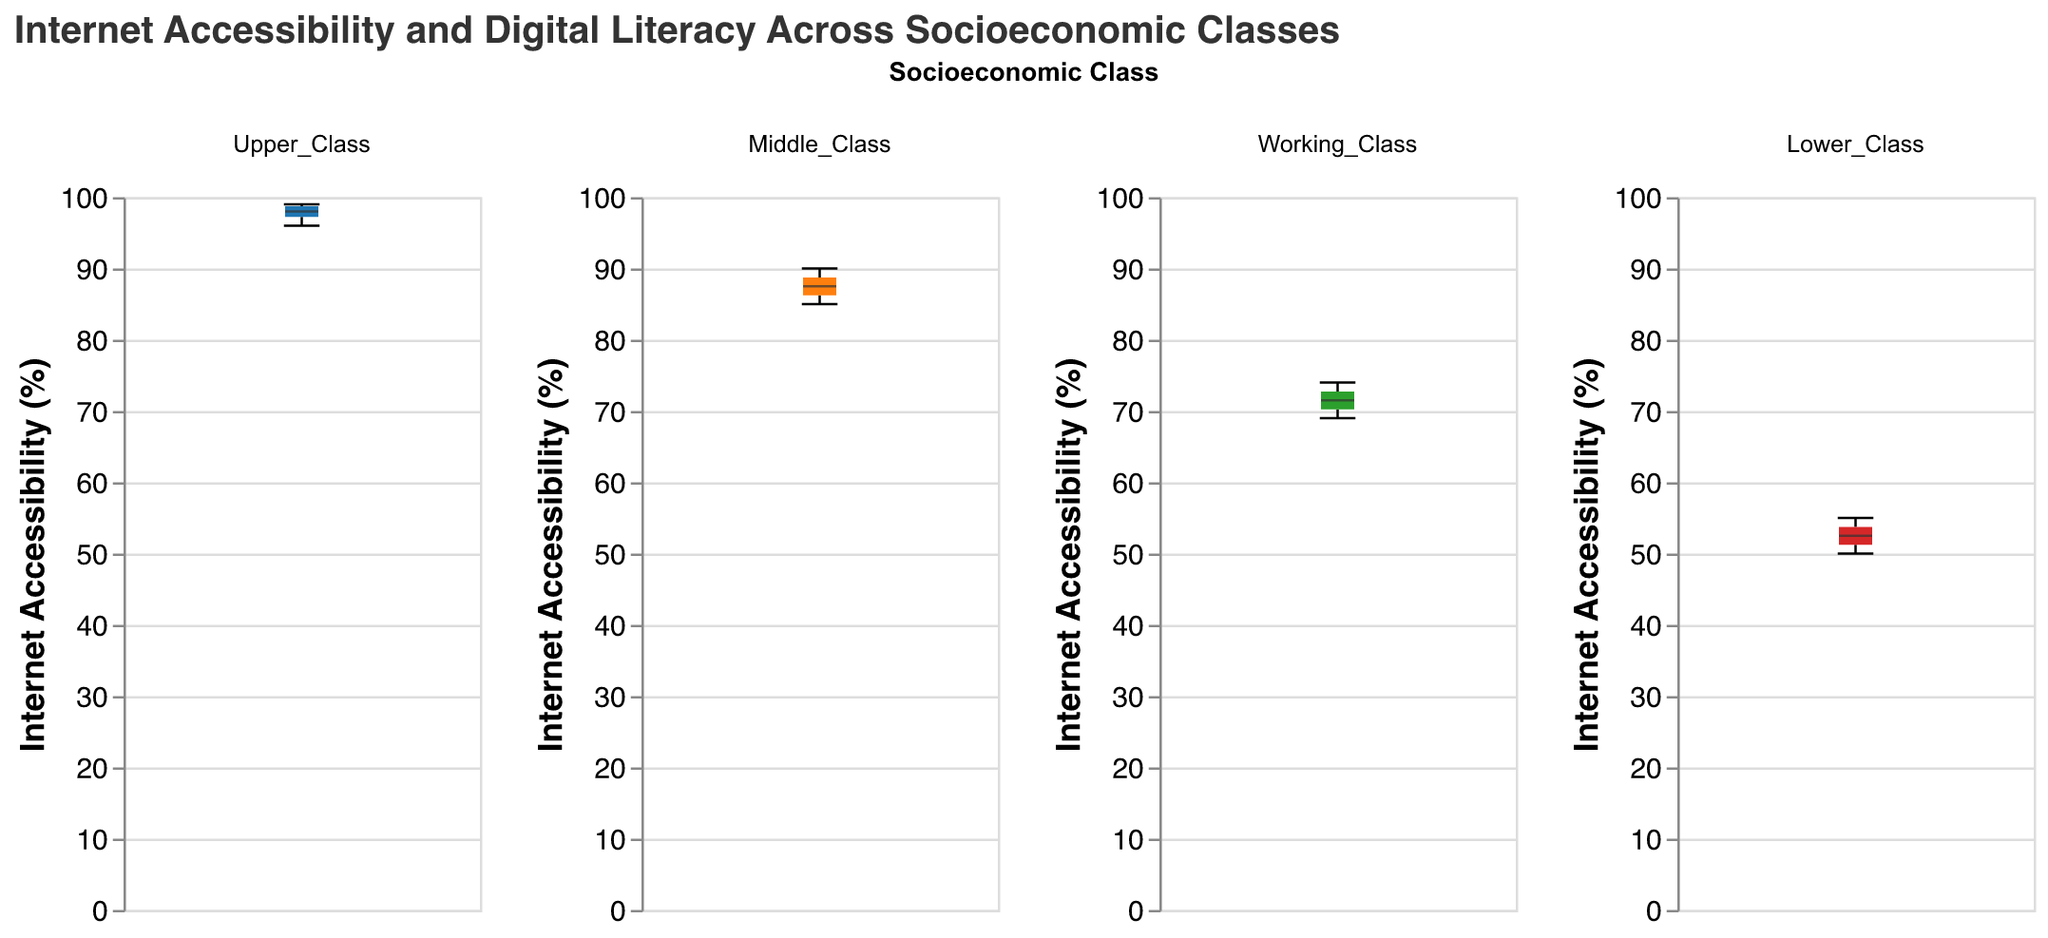What is the title of the figure? The title of the figure can be found at the top and reads "Internet Accessibility and Digital Literacy Across Socioeconomic Classes".
Answer: Internet Accessibility and Digital Literacy Across Socioeconomic Classes On which axis is the Internet Accessibility Percentage represented? The Internet Accessibility Percentage is represented on the y-axis of the plot.
Answer: y-axis Which socioeconomic class has the highest median Internet Accessibility Percentage? To find the median values, you need to look at the central line inside each box. The upper class has the highest median Internet Accessibility Percentage.
Answer: Upper Class How does the range of Internet Accessibility Percentage vary among the socioeconomic classes? The range is the difference between the maximum and minimum values within each box plot. Upper Class has the smallest range, Middle Class has a slightly larger range, Working Class has a larger range, and Lower Class has the largest range.
Answer: Lower Class > Working Class > Middle Class > Upper Class Compare the median Internet Accessibility Percentages between Middle Class and Working Class. The median value is represented by the line inside the box. For Middle Class, the median is around 87-88%, while for Working Class it is around 72-73%.
Answer: Middle Class > Working Class Which socioeconomic class shows the widest spread in Internet Accessibility Percentage? The spread is indicated by the length of the box-and-whisker. The Lower Class has the widest spread in Internet Accessibility Percentage.
Answer: Lower Class What is the range of Internet Accessibility Percentage for the Middle Class? The range is determined by the distance between the minimum and maximum values, indicated by the whiskers. For Middle Class, it ranges approximately from 85% to 90%.
Answer: 5% Identify the class with the least variability in Internet Accessibility Percentage. Variability is shown by the length of the box-and-whisker plot. The Upper Class has the least variability in Internet Accessibility Percentage.
Answer: Upper Class Which socioeconomic class has the lowest minimum Internet Accessibility Percentage? The minimum value can be identified by the lower whisker of the box plot. The Lower Class has the lowest minimum Internet Accessibility Percentage at around 50%.
Answer: Lower Class 